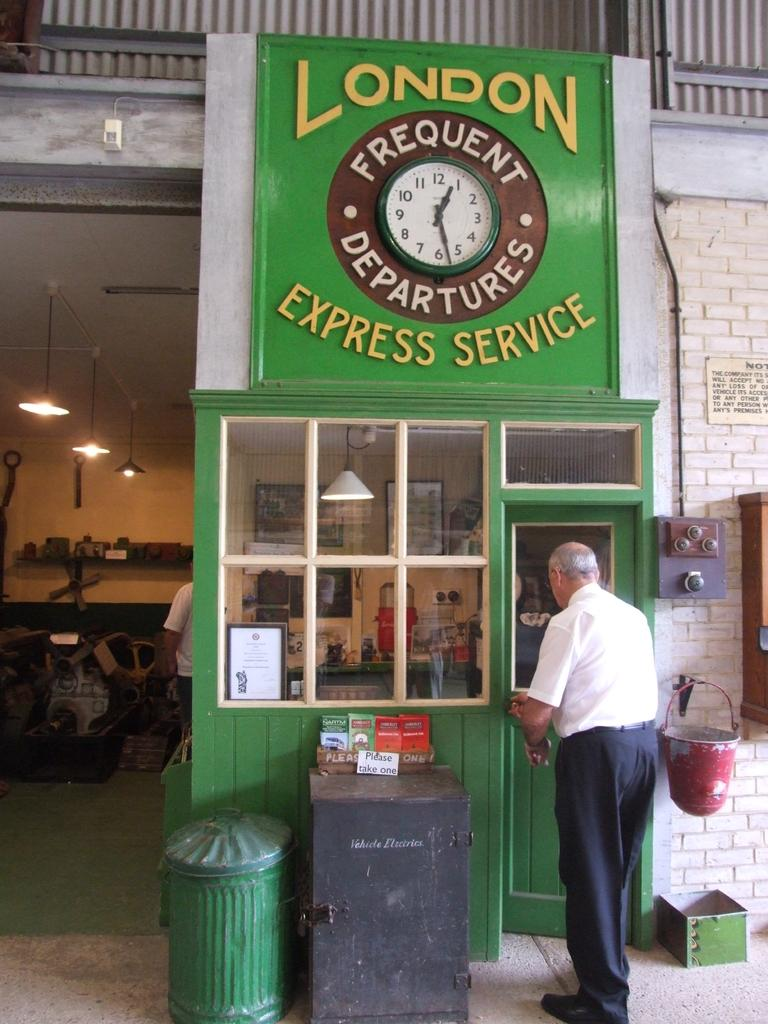What is the man in the image doing? The man is standing on the floor in the image. What can be seen in the image besides the man? There is a door, lamps, a wall, a bucket, and a person standing in the background. Can you describe the lighting in the image? The presence of lamps suggests that there is artificial lighting in the image. What is visible in the background of the image? In the background, there is a person standing and some objects visible. What type of owl can be seen wearing a crown in the image? There is no owl or crown present in the image. Can you describe the cloud formation in the image? There are no clouds visible in the image. 